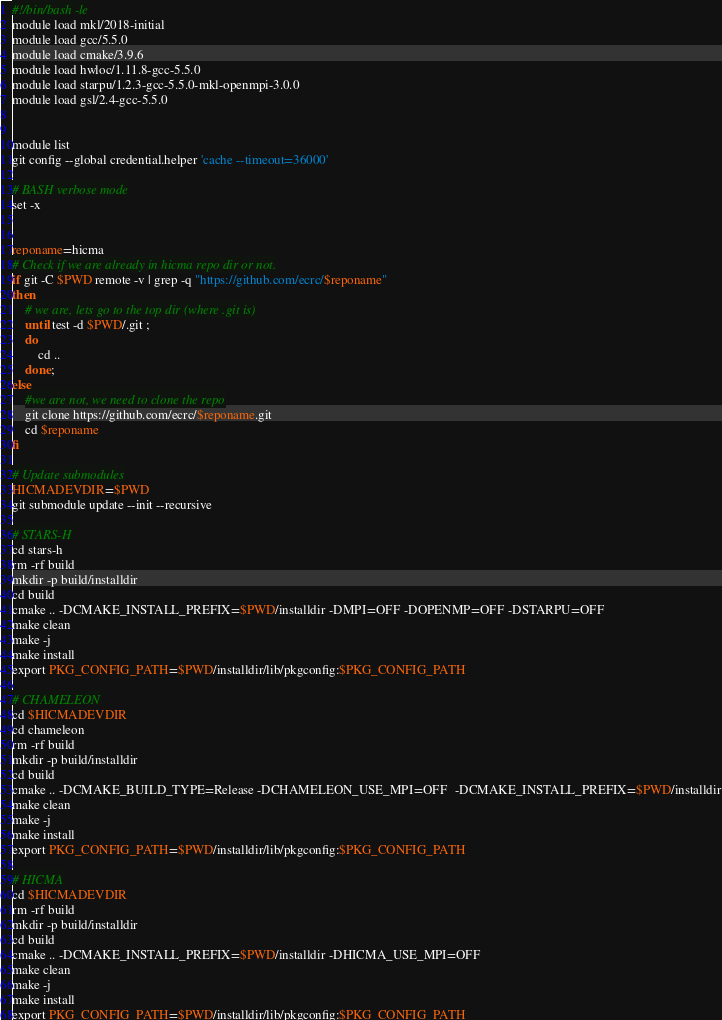Convert code to text. <code><loc_0><loc_0><loc_500><loc_500><_Bash_>#!/bin/bash -le
module load mkl/2018-initial
module load gcc/5.5.0
module load cmake/3.9.6
module load hwloc/1.11.8-gcc-5.5.0
module load starpu/1.2.3-gcc-5.5.0-mkl-openmpi-3.0.0
module load gsl/2.4-gcc-5.5.0


module list
git config --global credential.helper 'cache --timeout=36000'

# BASH verbose mode
set -x 


reponame=hicma
# Check if we are already in hicma repo dir or not.
if git -C $PWD remote -v | grep -q "https://github.com/ecrc/$reponame"
then
	# we are, lets go to the top dir (where .git is)
	until test -d $PWD/.git ;
	do
		cd ..
	done;
else
	#we are not, we need to clone the repo
	git clone https://github.com/ecrc/$reponame.git
	cd $reponame
fi

# Update submodules
HICMADEVDIR=$PWD 
git submodule update --init --recursive

# STARS-H
cd stars-h
rm -rf build
mkdir -p build/installdir
cd build
cmake .. -DCMAKE_INSTALL_PREFIX=$PWD/installdir -DMPI=OFF -DOPENMP=OFF -DSTARPU=OFF
make clean
make -j
make install
export PKG_CONFIG_PATH=$PWD/installdir/lib/pkgconfig:$PKG_CONFIG_PATH

# CHAMELEON
cd $HICMADEVDIR
cd chameleon
rm -rf build
mkdir -p build/installdir
cd build
cmake .. -DCMAKE_BUILD_TYPE=Release -DCHAMELEON_USE_MPI=OFF  -DCMAKE_INSTALL_PREFIX=$PWD/installdir
make clean
make -j
make install
export PKG_CONFIG_PATH=$PWD/installdir/lib/pkgconfig:$PKG_CONFIG_PATH

# HICMA
cd $HICMADEVDIR
rm -rf build
mkdir -p build/installdir
cd build
cmake .. -DCMAKE_INSTALL_PREFIX=$PWD/installdir -DHICMA_USE_MPI=OFF
make clean
make -j
make install
export PKG_CONFIG_PATH=$PWD/installdir/lib/pkgconfig:$PKG_CONFIG_PATH

</code> 